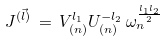<formula> <loc_0><loc_0><loc_500><loc_500>J ^ { ( \vec { l } ) } \, = \, V ^ { l _ { 1 } } _ { ( n ) } U _ { ( n ) } ^ { - l _ { 2 } } \, \omega _ { n } ^ { \frac { l _ { 1 } l _ { 2 } } { 2 } }</formula> 